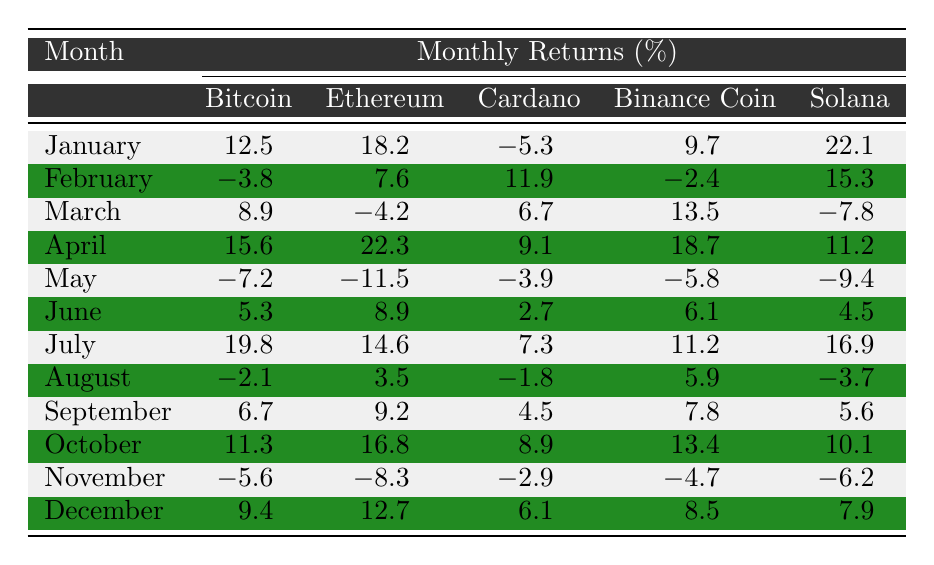What was the highest monthly return for Bitcoin? Looking at the Bitcoin column, the highest value is 19.8 in July.
Answer: 19.8 In which month did Ethereum have its lowest return? In the Ethereum column, the lowest value is -11.5, which occurs in May.
Answer: May What is the average monthly return of Cardano throughout the year? The sum of Cardano returns is (-5.3 + 11.9 + 6.7 + 9.1 - 3.9 + 2.7 + 7.3 - 1.8 + 4.5 + 8.9 - 2.9 + 6.1) = 38.6. There are 12 months, so the average is 38.6 / 12 = 3.22.
Answer: 3.2 Did Binance Coin ever have a negative return? Yes, there are instances of negative returns: -2.4 in February and -4.7 in November.
Answer: Yes Which cryptocurrency had the best performance in December? Reviewing December's returns, Solana had 7.9, which is the highest compared to others (Bitcoin 9.4, Ethereum 12.7, Cardano 6.1, Binance Coin 8.5).
Answer: Ethereum What was the total return for Solana from January to December? The total return for Solana is the sum of all monthly returns: (22.1 + 15.3 - 7.8 + 11.2 - 9.4 + 4.5 + 16.9 - 3.7 + 5.6 + 10.1 - 6.2 + 7.9) = 64.1.
Answer: 64.1 What percentage of months did Bitcoin have a positive return? Bitcoin had positive returns in January, March, April, June, July, September, October, and December, totaling 8 months out of 12. Hence, the percentage is (8 / 12) * 100 = 66.67%.
Answer: 66.67% Which cryptocurrency had the most consistent returns throughout the year? Analyzing the monthly fluctuations, we can observe that Ethereum had fewer extreme values (one negative) compared to others, indicating more consistency.
Answer: Ethereum In terms of overall performance, which cryptocurrency had the highest average return? Calculate the average returns: Bitcoin 5.25, Ethereum 5.41, Cardano 2.42, Binance Coin 7.12, Solana 5.34. Binance Coin has the highest average return.
Answer: Binance Coin How many months saw returns above 15% for Ethereum? Ethereum had returns above 15% in January (18.2), April (22.3), and July (14.6). So, there are 3 months.
Answer: 3 